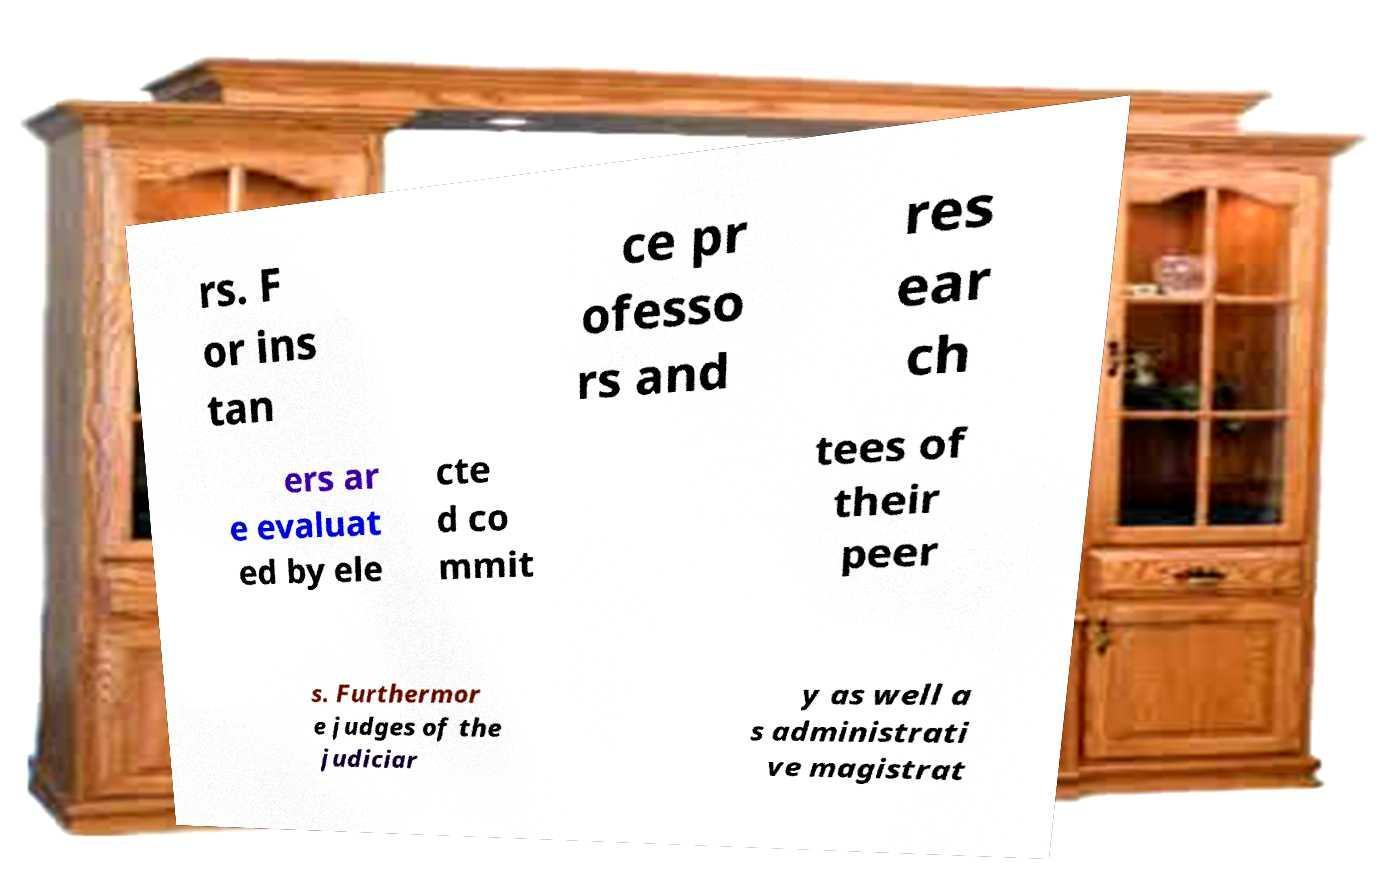There's text embedded in this image that I need extracted. Can you transcribe it verbatim? rs. F or ins tan ce pr ofesso rs and res ear ch ers ar e evaluat ed by ele cte d co mmit tees of their peer s. Furthermor e judges of the judiciar y as well a s administrati ve magistrat 